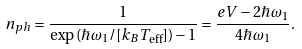<formula> <loc_0><loc_0><loc_500><loc_500>n _ { p h } = \frac { 1 } { \exp \left ( \hbar { \omega } _ { 1 } / [ k _ { B } T _ { \text {eff} } ] \right ) - 1 } = \frac { e V - 2 \hbar { \omega } _ { 1 } } { 4 \hbar { \omega } _ { 1 } } .</formula> 